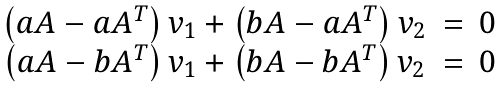Convert formula to latex. <formula><loc_0><loc_0><loc_500><loc_500>\begin{matrix} \left ( a A - a A ^ { T } \right ) v _ { 1 } + \left ( b A - a A ^ { T } \right ) v _ { 2 } & = & 0 \\ \left ( a A - b A ^ { T } \right ) v _ { 1 } + \left ( b A - b A ^ { T } \right ) v _ { 2 } & = & 0 \end{matrix}</formula> 